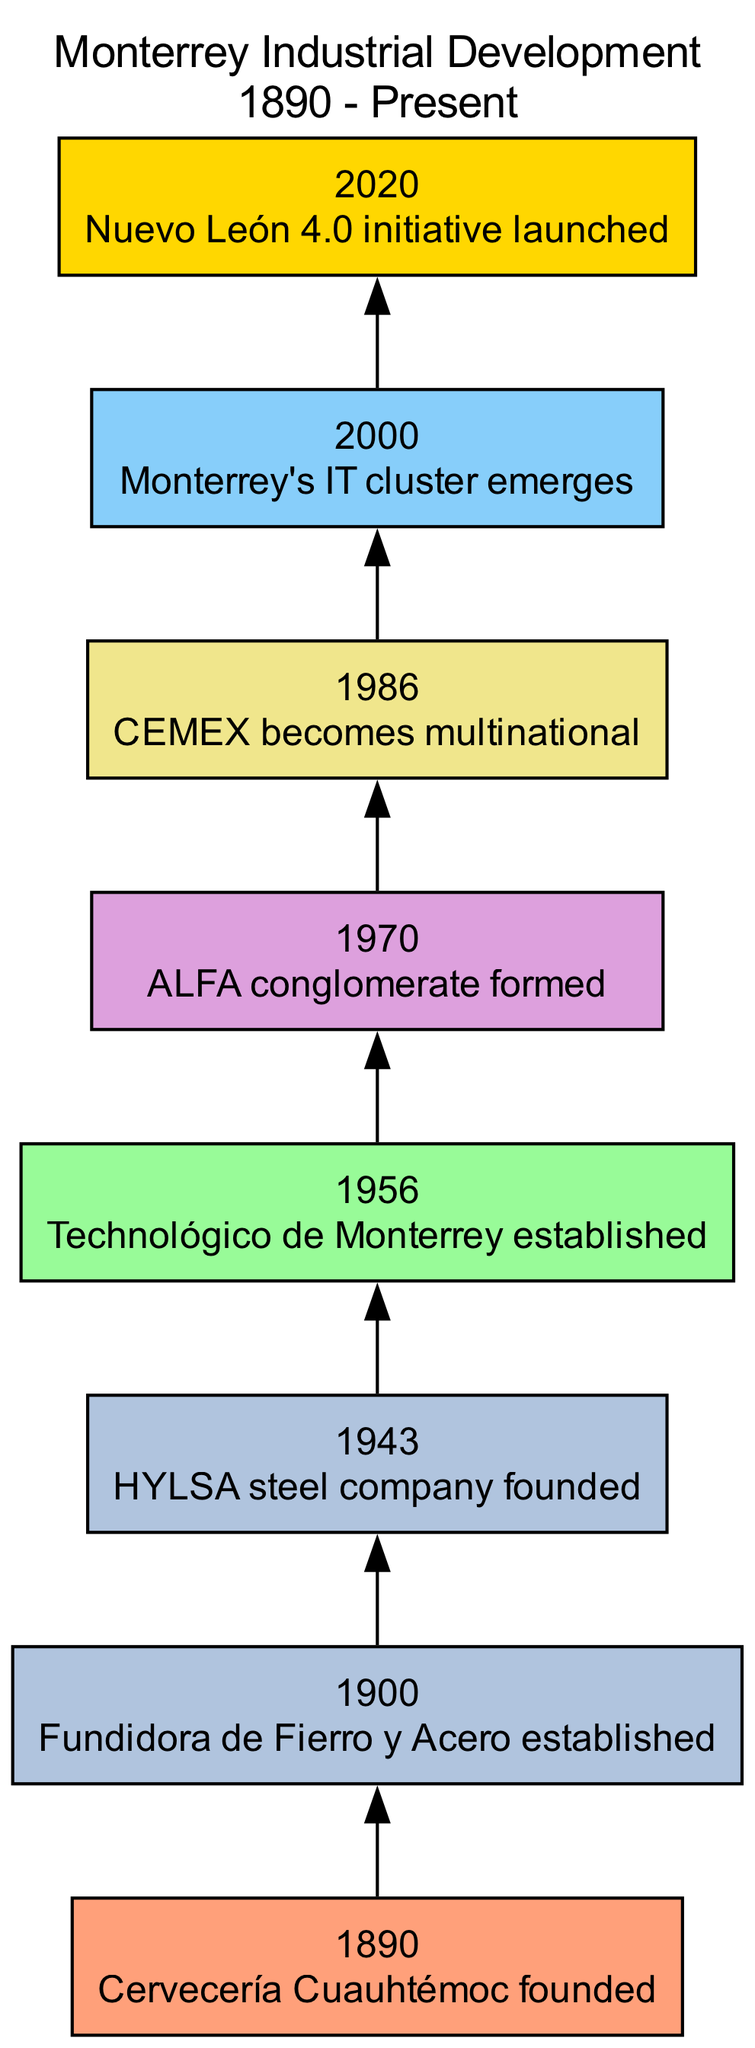What event marks the beginning of Monterrey's industrial timeline? The timeline starts in 1890 with the founding of Cervecería Cuauhtémoc. This event is represented at the very top of the diagram, indicating the beginning of Monterrey's industrial development.
Answer: Cervecería Cuauhtémoc How many major industries are listed in the timeline? By examining the industries associated with each event in the timeline, we can count the distinct types. The industries include Brewing, Steel, Education, Diversified, Cement, Technology, and Innovation, totaling seven unique industries.
Answer: 7 What year was the ALFA conglomerate formed? According to the diagram, ALFA was founded in the year 1970. This information can be found in the section of the timeline that corresponds to that specific event.
Answer: 1970 Which industry does CEMEX belong to? The timeline indicates that CEMEX is associated with the Cement industry, as noted in the 1986 event where it became multinational.
Answer: Cement What significant education institution was established in Monterrey in 1956? Referring to the timeline, it shows that the Technológico de Monterrey was established in 1956, marking a significant development in the education sector.
Answer: Technológico de Monterrey Which two steel companies are identified in the timeline? The events in the timeline indicate two steel companies: Fundidora de Fierro y Acero, established in 1900, and HYLSA, founded in 1943. Both events are connected by their industry type and can be visually traced within the diagram.
Answer: Fundidora de Fierro y Acero and HYLSA What milestone happened in 2020? The diagram clearly marks 2020 as the year when the Nuevo León 4.0 initiative was launched, representing a milestone in the innovation sector.
Answer: Nuevo León 4.0 initiative Which industry emerged in Monterrey around the year 2000? Referring to the timeline, the IT cluster emerged in Monterrey in the year 2000, indicating a significant development within the Technology industry.
Answer: Technology 